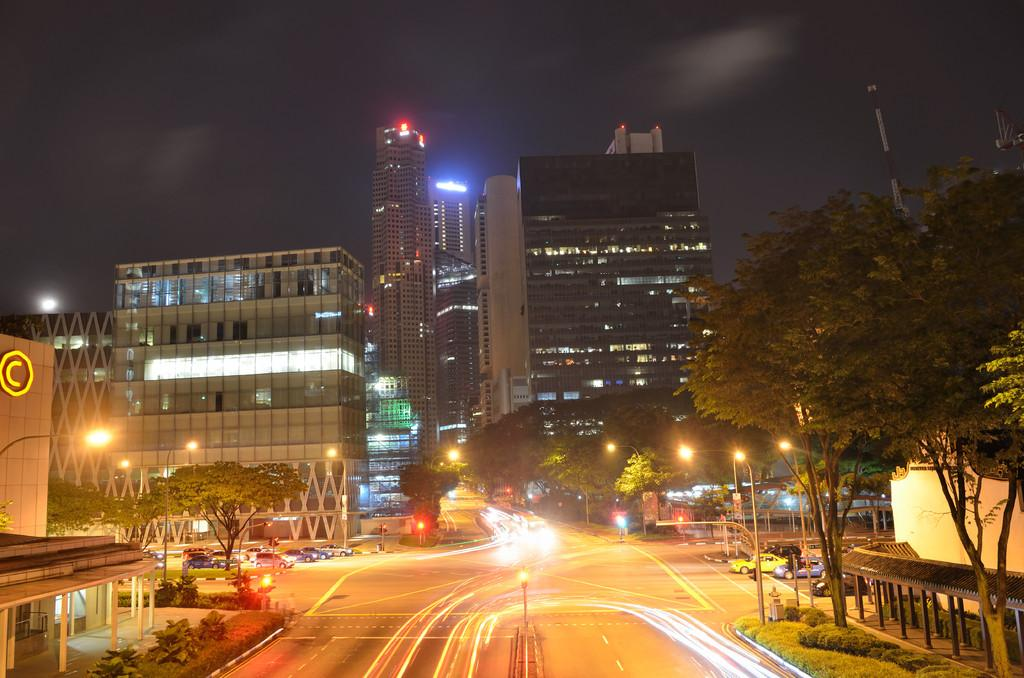What type of structures can be seen in the image? There are buildings in the image. What other natural elements are present in the image? There are trees in the image. What mode of transportation can be seen on the road in the image? Motor vehicles are present on the road in the image. What are the vertical structures on the sides of the road? Street poles are visible in the image. What type of lighting is present in the image? Street lights are present in the image. What tall structures can be seen in the distance? Towers are visible in the image. What part of the natural environment is visible in the image? The sky is visible in the image. What type of cream can be seen on the buildings in the image? There is no cream present on the buildings in the image. What color is the gold used to decorate the trees in the image? There is no gold used to decorate the trees in the image; they are natural trees. 